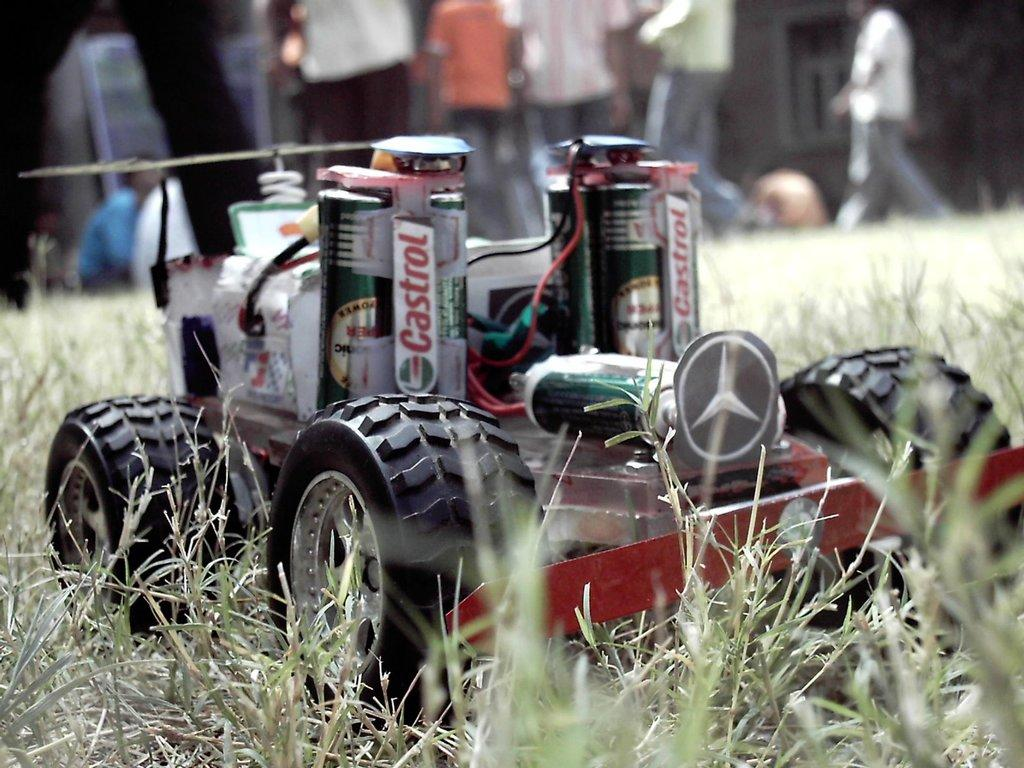What type of car is in the image? There is a remote car in the image. Where is the remote car located? The remote car is on a grassland. Can you describe the people in the background of the image? There are people standing in the background of the image. How is the background of the image depicted? The background is blurred. What type of cushion can be seen in the image? There is no cushion present in the image. Is there any sleet visible in the image? There is no mention of sleet in the provided facts, and it is not visible in the image. 